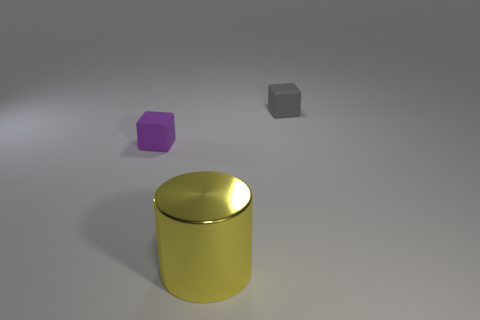What size is the thing that is left of the tiny gray cube and to the right of the purple rubber cube?
Your response must be concise. Large. How many objects are on the left side of the big yellow metal thing?
Offer a terse response. 1. There is a thing that is both in front of the small gray rubber cube and behind the metallic cylinder; what is its shape?
Offer a very short reply. Cube. How many blocks are either yellow metal objects or tiny cyan metallic things?
Provide a short and direct response. 0. Is the number of yellow cylinders on the right side of the small gray matte block less than the number of big cyan rubber cubes?
Offer a terse response. No. What color is the object that is to the right of the tiny purple cube and behind the big metal cylinder?
Ensure brevity in your answer.  Gray. What number of other things are there of the same shape as the yellow shiny object?
Your response must be concise. 0. Are there fewer small cubes behind the purple matte block than large yellow cylinders in front of the yellow object?
Keep it short and to the point. No. Is the gray block made of the same material as the object on the left side of the large metal cylinder?
Provide a short and direct response. Yes. Is there any other thing that has the same material as the large yellow cylinder?
Make the answer very short. No. 